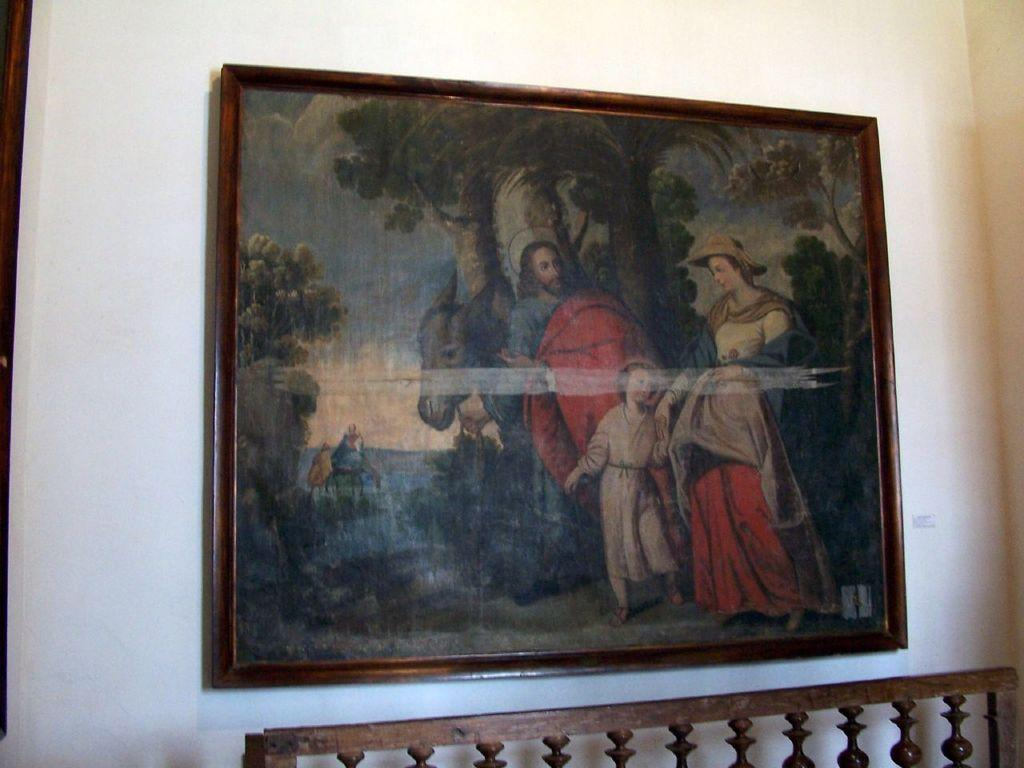What is the main subject of the image? There is a painting in the image. Where is the painting located? The painting is attached to a wall. What color is the wall that the painting is attached to? The wall is white in color. What color is the partner of the person in the painting? There is no person in the painting, and therefore no partner is depicted. 